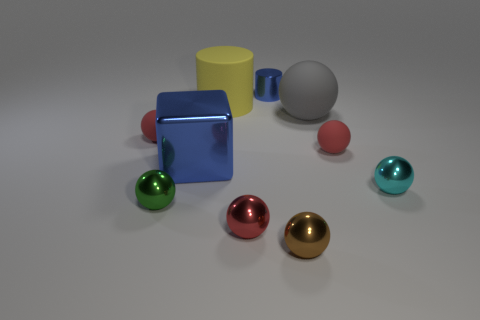Subtract all red balls. How many were subtracted if there are1red balls left? 2 Subtract all red cylinders. How many red balls are left? 3 Subtract all red spheres. How many spheres are left? 4 Subtract all tiny cyan spheres. How many spheres are left? 6 Subtract all green spheres. Subtract all purple cylinders. How many spheres are left? 6 Subtract all blocks. How many objects are left? 9 Add 9 small shiny cylinders. How many small shiny cylinders are left? 10 Add 8 gray matte things. How many gray matte things exist? 9 Subtract 1 cyan balls. How many objects are left? 9 Subtract all small red rubber balls. Subtract all tiny red shiny things. How many objects are left? 7 